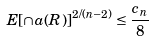Convert formula to latex. <formula><loc_0><loc_0><loc_500><loc_500>E [ \cap a ( R ) ] ^ { 2 / ( n - 2 ) } \leq \frac { c _ { n } } { 8 }</formula> 